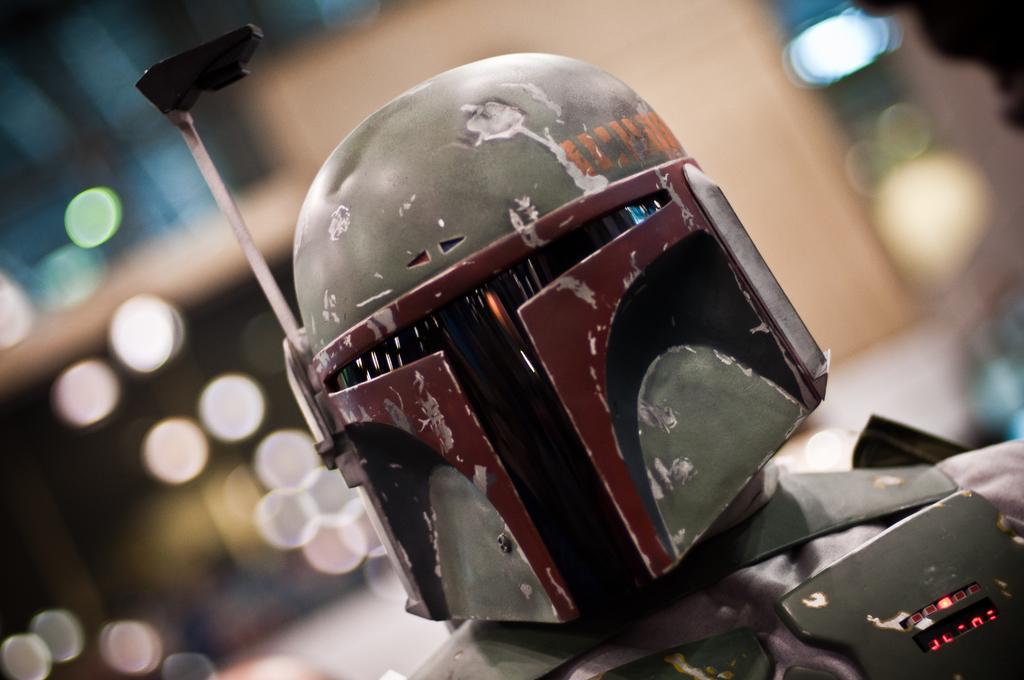Who or what can be seen in the image? There is a person in the image. What is the person wearing? The person is wearing a costume. Can you describe the background of the image? The background of the image is blurred. What type of silk is being used to write a letter in the image? There is no silk or letter present in the image. What scientific experiment is being conducted in the image? There is no scientific experiment being conducted in the image. 